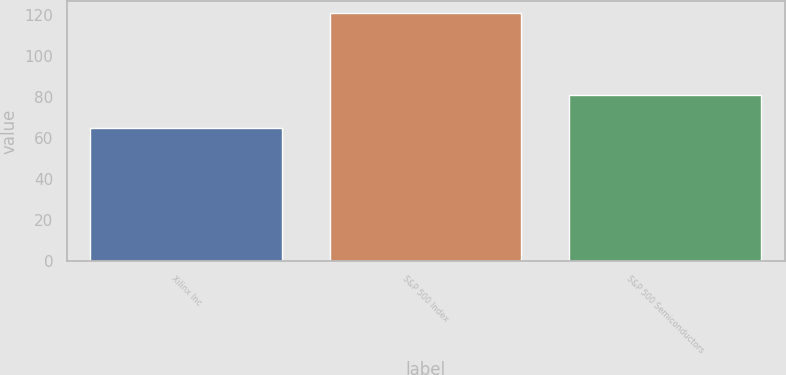Convert chart. <chart><loc_0><loc_0><loc_500><loc_500><bar_chart><fcel>Xilinx Inc<fcel>S&P 500 Index<fcel>S&P 500 Semiconductors<nl><fcel>64.95<fcel>121.19<fcel>81.2<nl></chart> 